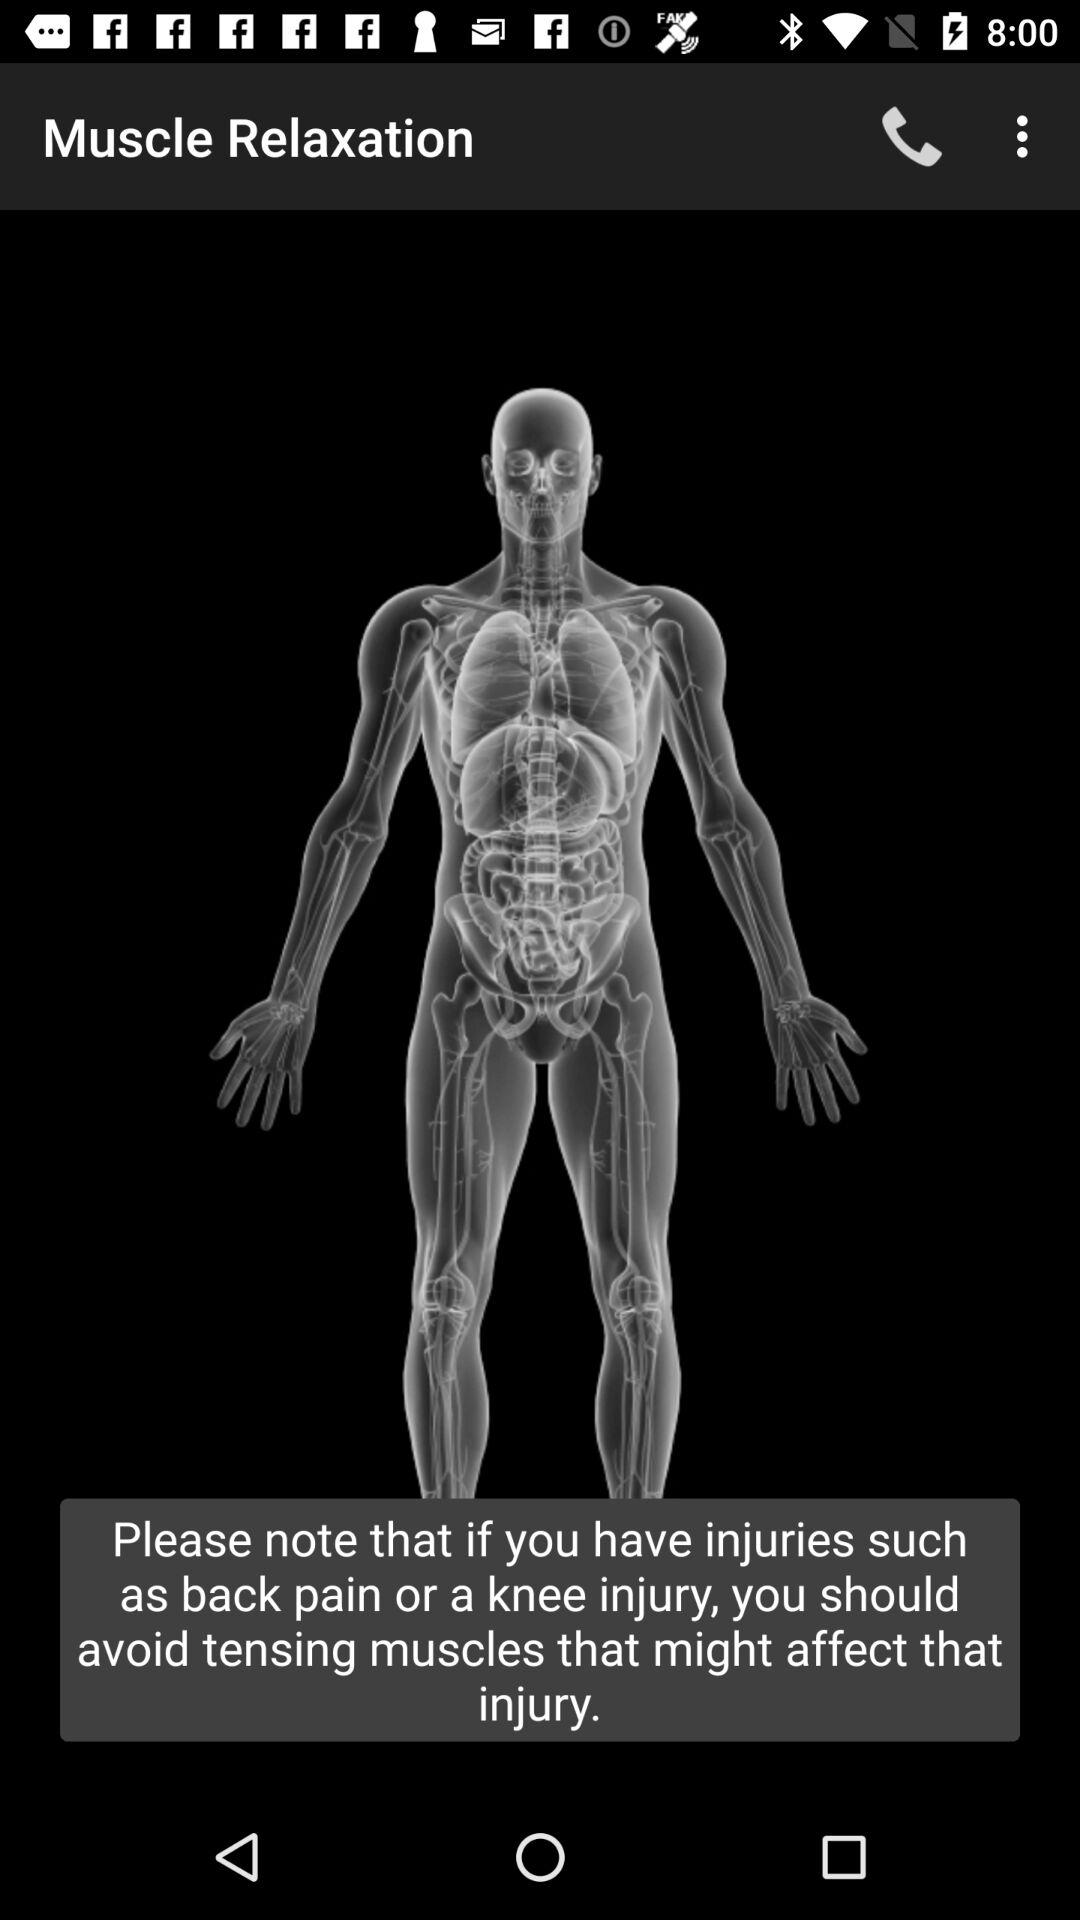What is the name of the application? The name of the application is "Muscle Relaxation". 